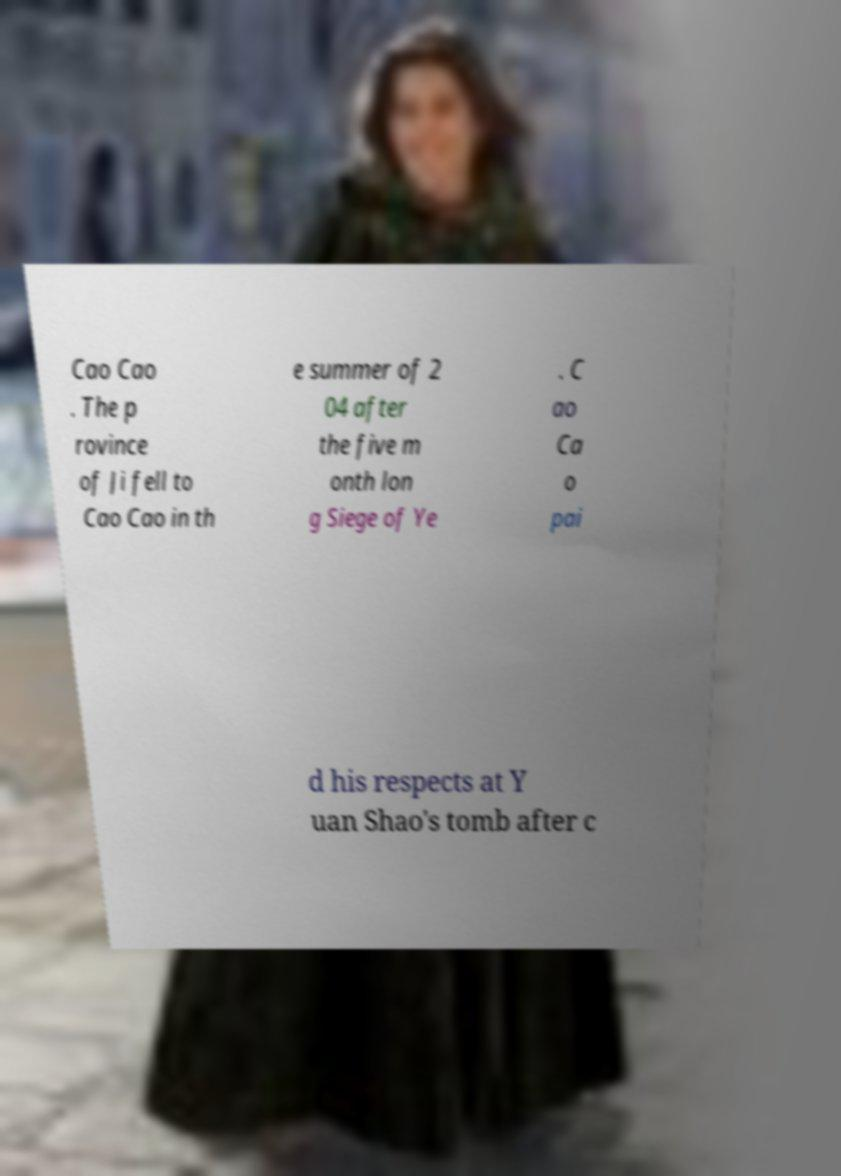I need the written content from this picture converted into text. Can you do that? Cao Cao . The p rovince of Ji fell to Cao Cao in th e summer of 2 04 after the five m onth lon g Siege of Ye . C ao Ca o pai d his respects at Y uan Shao's tomb after c 